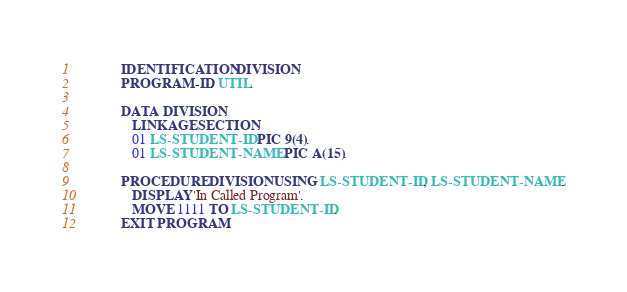<code> <loc_0><loc_0><loc_500><loc_500><_COBOL_>            IDENTIFICATION DIVISION.
            PROGRAM-ID. UTIL.

            DATA DIVISION.
               LINKAGE SECTION.
               01 LS-STUDENT-ID PIC 9(4).
               01 LS-STUDENT-NAME PIC A(15).

            PROCEDURE DIVISION USING LS-STUDENT-ID, LS-STUDENT-NAME.
               DISPLAY 'In Called Program'.
               MOVE 1111 TO LS-STUDENT-ID.
            EXIT PROGRAM.
</code> 